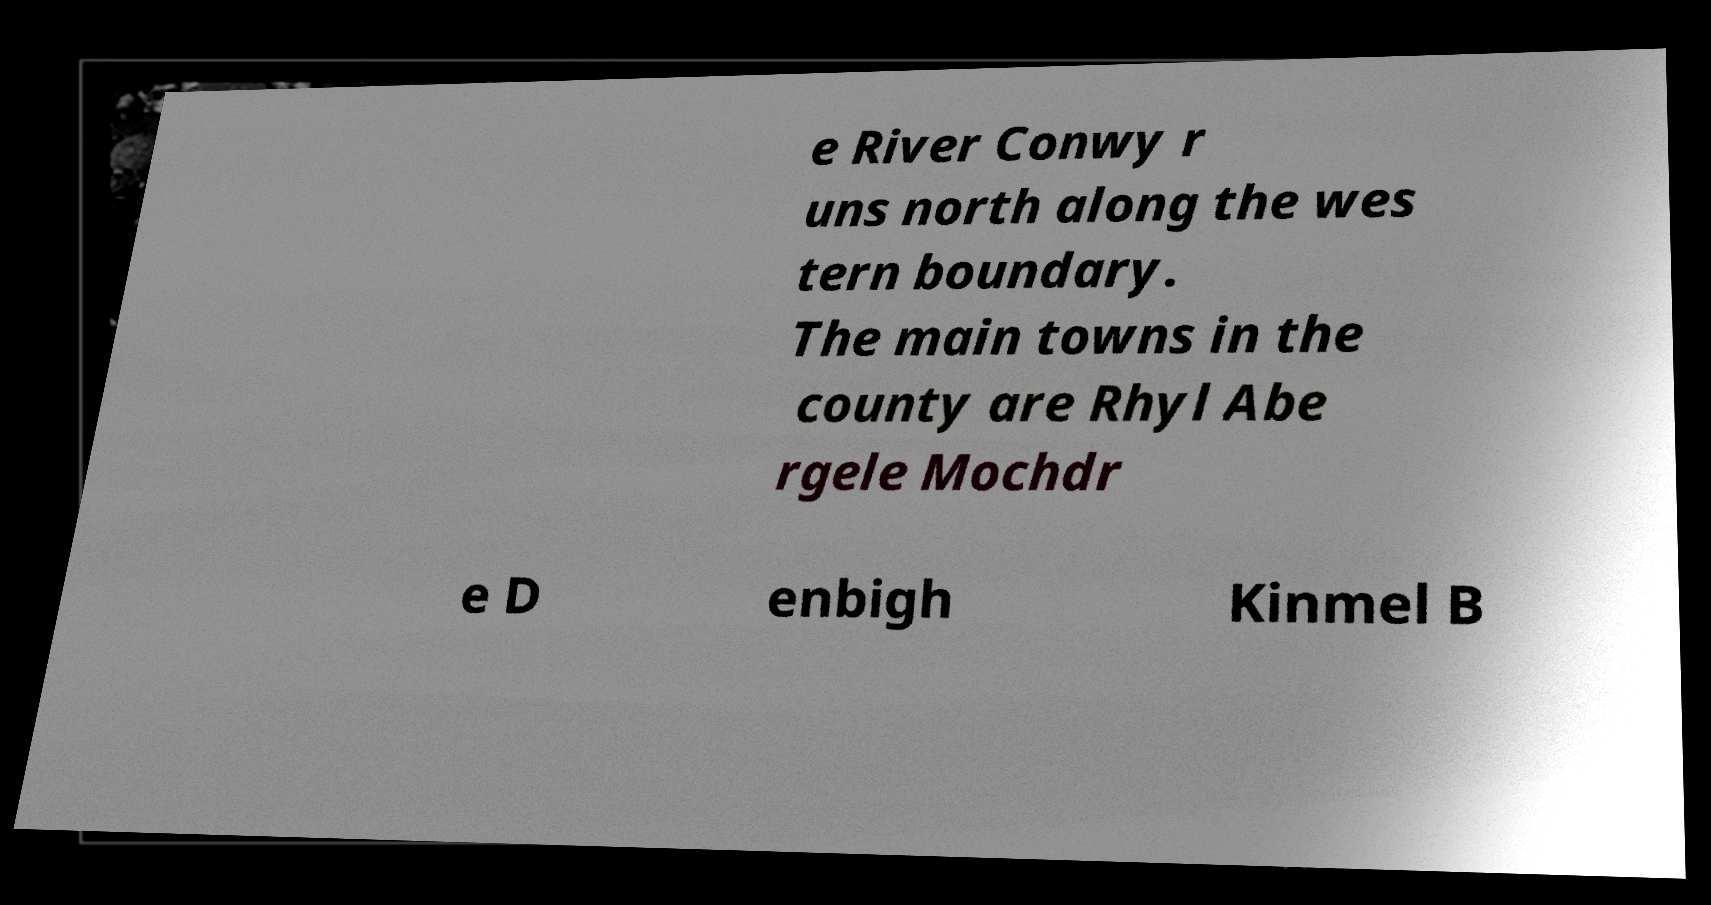Could you assist in decoding the text presented in this image and type it out clearly? e River Conwy r uns north along the wes tern boundary. The main towns in the county are Rhyl Abe rgele Mochdr e D enbigh Kinmel B 